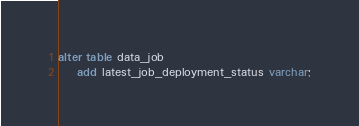<code> <loc_0><loc_0><loc_500><loc_500><_SQL_>alter table data_job
    add latest_job_deployment_status varchar;
</code> 